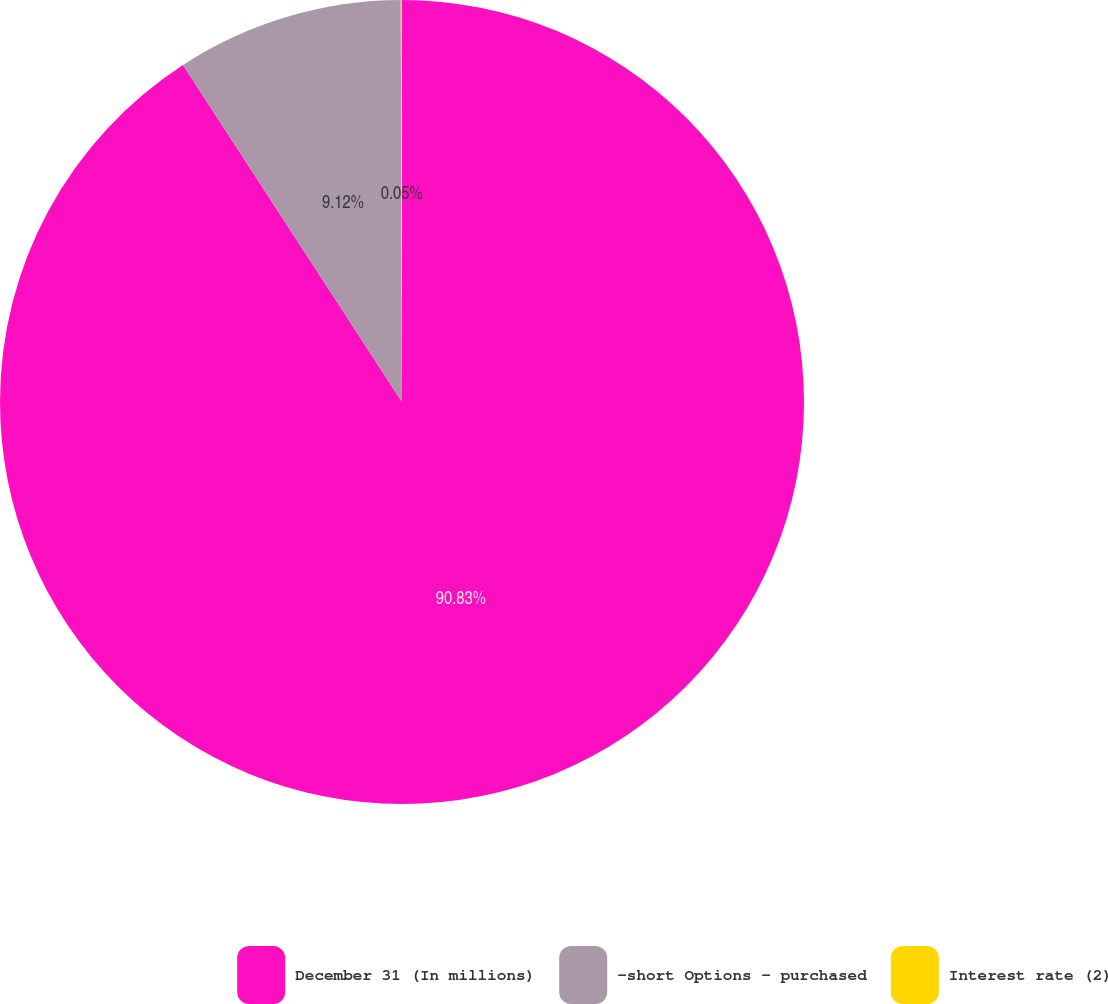Convert chart to OTSL. <chart><loc_0><loc_0><loc_500><loc_500><pie_chart><fcel>December 31 (In millions)<fcel>-short Options - purchased<fcel>Interest rate (2)<nl><fcel>90.83%<fcel>9.12%<fcel>0.05%<nl></chart> 